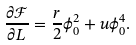<formula> <loc_0><loc_0><loc_500><loc_500>\frac { \partial \mathcal { F } } { \partial L } = \frac { r } { 2 } \phi _ { 0 } ^ { 2 } + u \phi _ { 0 } ^ { 4 } .</formula> 